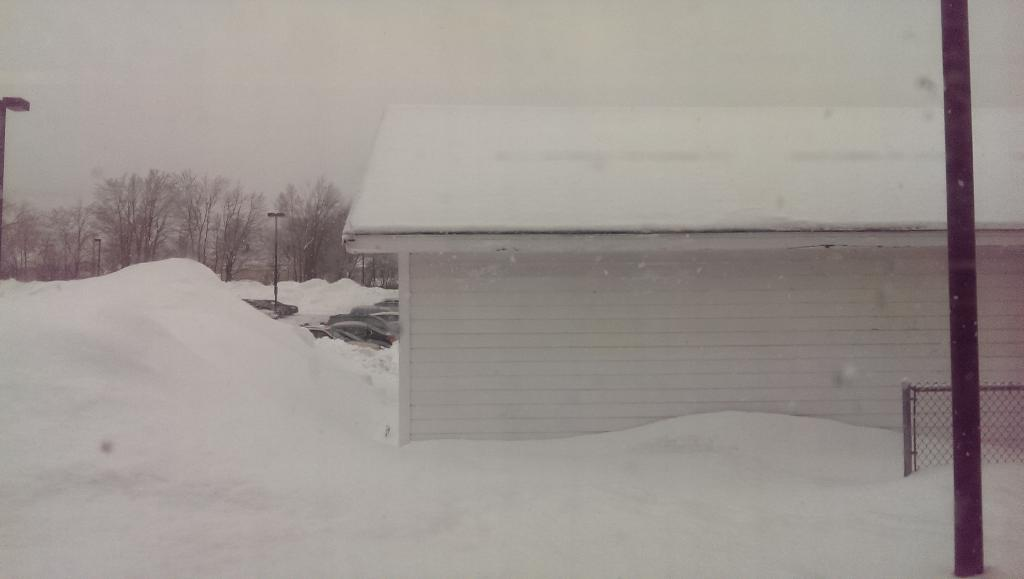What type of structure is present in the image? There is a shed in the image. What is the weather like in the image? There is snow visible in the image, indicating a cold or wintery environment. What else can be seen in the image besides the shed? There are poles, trees, and a mesh on the right side of the image. What is visible in the background of the image? The sky is visible in the background of the image. What type of agreement was reached between the two nations depicted in the image? There are no nations or any indication of an agreement in the image; it features a shed, snow, poles, trees, and a mesh. 